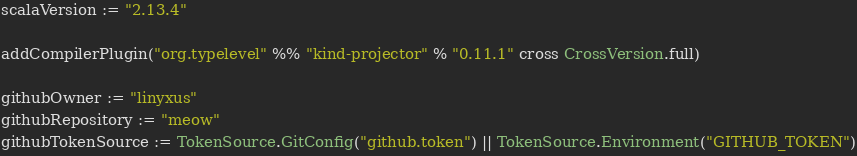Convert code to text. <code><loc_0><loc_0><loc_500><loc_500><_Scala_>scalaVersion := "2.13.4"

addCompilerPlugin("org.typelevel" %% "kind-projector" % "0.11.1" cross CrossVersion.full)

githubOwner := "linyxus"
githubRepository := "meow"
githubTokenSource := TokenSource.GitConfig("github.token") || TokenSource.Environment("GITHUB_TOKEN")
</code> 